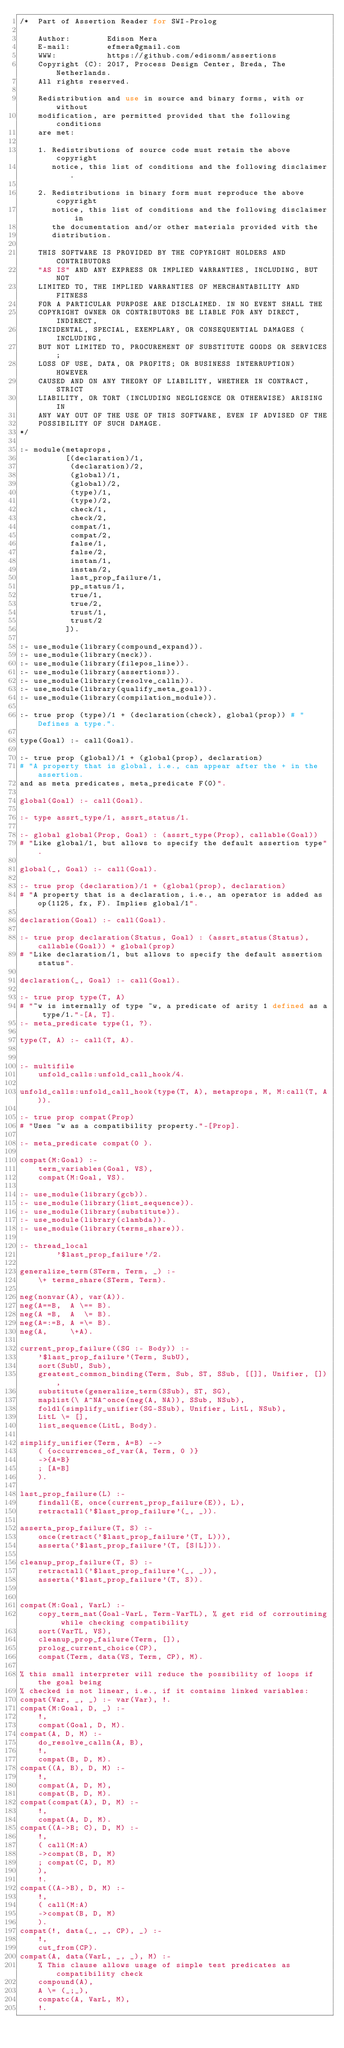Convert code to text. <code><loc_0><loc_0><loc_500><loc_500><_Perl_>/*  Part of Assertion Reader for SWI-Prolog

    Author:        Edison Mera
    E-mail:        efmera@gmail.com
    WWW:           https://github.com/edisonm/assertions
    Copyright (C): 2017, Process Design Center, Breda, The Netherlands.
    All rights reserved.

    Redistribution and use in source and binary forms, with or without
    modification, are permitted provided that the following conditions
    are met:

    1. Redistributions of source code must retain the above copyright
       notice, this list of conditions and the following disclaimer.

    2. Redistributions in binary form must reproduce the above copyright
       notice, this list of conditions and the following disclaimer in
       the documentation and/or other materials provided with the
       distribution.

    THIS SOFTWARE IS PROVIDED BY THE COPYRIGHT HOLDERS AND CONTRIBUTORS
    "AS IS" AND ANY EXPRESS OR IMPLIED WARRANTIES, INCLUDING, BUT NOT
    LIMITED TO, THE IMPLIED WARRANTIES OF MERCHANTABILITY AND FITNESS
    FOR A PARTICULAR PURPOSE ARE DISCLAIMED. IN NO EVENT SHALL THE
    COPYRIGHT OWNER OR CONTRIBUTORS BE LIABLE FOR ANY DIRECT, INDIRECT,
    INCIDENTAL, SPECIAL, EXEMPLARY, OR CONSEQUENTIAL DAMAGES (INCLUDING,
    BUT NOT LIMITED TO, PROCUREMENT OF SUBSTITUTE GOODS OR SERVICES;
    LOSS OF USE, DATA, OR PROFITS; OR BUSINESS INTERRUPTION) HOWEVER
    CAUSED AND ON ANY THEORY OF LIABILITY, WHETHER IN CONTRACT, STRICT
    LIABILITY, OR TORT (INCLUDING NEGLIGENCE OR OTHERWISE) ARISING IN
    ANY WAY OUT OF THE USE OF THIS SOFTWARE, EVEN IF ADVISED OF THE
    POSSIBILITY OF SUCH DAMAGE.
*/

:- module(metaprops,
          [(declaration)/1,
           (declaration)/2,
           (global)/1,
           (global)/2,
           (type)/1,
           (type)/2,
           check/1,
           check/2,
           compat/1,
           compat/2,
           false/1,
           false/2,
           instan/1,
           instan/2,
           last_prop_failure/1,
           pp_status/1,
           true/1,
           true/2,
           trust/1,
           trust/2
          ]).

:- use_module(library(compound_expand)).
:- use_module(library(neck)).
:- use_module(library(filepos_line)).
:- use_module(library(assertions)).
:- use_module(library(resolve_calln)).
:- use_module(library(qualify_meta_goal)).
:- use_module(library(compilation_module)).

:- true prop (type)/1 + (declaration(check), global(prop)) # "Defines a type.".

type(Goal) :- call(Goal).

:- true prop (global)/1 + (global(prop), declaration)
# "A property that is global, i.e., can appear after the + in the assertion.
and as meta predicates, meta_predicate F(0)".

global(Goal) :- call(Goal).

:- type assrt_type/1, assrt_status/1.

:- global global(Prop, Goal) : (assrt_type(Prop), callable(Goal))
# "Like global/1, but allows to specify the default assertion type".

global(_, Goal) :- call(Goal).

:- true prop (declaration)/1 + (global(prop), declaration)
# "A property that is a declaration, i.e., an operator is added as op(1125, fx, F). Implies global/1".

declaration(Goal) :- call(Goal).

:- true prop declaration(Status, Goal) : (assrt_status(Status), callable(Goal)) + global(prop)
# "Like declaration/1, but allows to specify the default assertion status".

declaration(_, Goal) :- call(Goal).

:- true prop type(T, A)
# "~w is internally of type ~w, a predicate of arity 1 defined as a type/1."-[A, T].
:- meta_predicate type(1, ?).

type(T, A) :- call(T, A).


:- multifile
    unfold_calls:unfold_call_hook/4.

unfold_calls:unfold_call_hook(type(T, A), metaprops, M, M:call(T, A)).

:- true prop compat(Prop)
# "Uses ~w as a compatibility property."-[Prop].

:- meta_predicate compat(0 ).

compat(M:Goal) :-
    term_variables(Goal, VS),
    compat(M:Goal, VS).

:- use_module(library(gcb)).
:- use_module(library(list_sequence)).
:- use_module(library(substitute)).
:- use_module(library(clambda)).
:- use_module(library(terms_share)).

:- thread_local
        '$last_prop_failure'/2.

generalize_term(STerm, Term, _) :-
    \+ terms_share(STerm, Term).

neg(nonvar(A), var(A)).
neg(A==B,  A \== B).
neg(A =B,  A  \= B).
neg(A=:=B, A =\= B).
neg(A,     \+A).

current_prop_failure((SG :- Body)) :-
    '$last_prop_failure'(Term, SubU),
    sort(SubU, Sub),
    greatest_common_binding(Term, Sub, ST, SSub, [[]], Unifier, []),
    substitute(generalize_term(SSub), ST, SG),
    maplist(\ A^NA^once(neg(A, NA)), SSub, NSub),
    foldl(simplify_unifier(SG-SSub), Unifier, LitL, NSub),
    LitL \= [],
    list_sequence(LitL, Body).

simplify_unifier(Term, A=B) -->
    ( {occurrences_of_var(A, Term, 0 )}
    ->{A=B}
    ; [A=B]
    ).

last_prop_failure(L) :-
    findall(E, once(current_prop_failure(E)), L),
    retractall('$last_prop_failure'(_, _)).

asserta_prop_failure(T, S) :-
    once(retract('$last_prop_failure'(T, L))),
    asserta('$last_prop_failure'(T, [S|L])).

cleanup_prop_failure(T, S) :-
    retractall('$last_prop_failure'(_, _)),
    asserta('$last_prop_failure'(T, S)).


compat(M:Goal, VarL) :-
    copy_term_nat(Goal-VarL, Term-VarTL), % get rid of corroutining while checking compatibility
    sort(VarTL, VS),
    cleanup_prop_failure(Term, []),
    prolog_current_choice(CP),
    compat(Term, data(VS, Term, CP), M).

% this small interpreter will reduce the possibility of loops if the goal being
% checked is not linear, i.e., if it contains linked variables:
compat(Var, _, _) :- var(Var), !.
compat(M:Goal, D, _) :-
    !,
    compat(Goal, D, M).
compat(A, D, M) :-
    do_resolve_calln(A, B),
    !,
    compat(B, D, M).
compat((A, B), D, M) :-
    !,
    compat(A, D, M),
    compat(B, D, M).
compat(compat(A), D, M) :-
    !,
    compat(A, D, M).
compat((A->B; C), D, M) :-
    !,
    ( call(M:A)
    ->compat(B, D, M)
    ; compat(C, D, M)
    ),
    !.
compat((A->B), D, M) :-
    !,
    ( call(M:A)
    ->compat(B, D, M)
    ).
compat(!, data(_, _, CP), _) :-
    !,
    cut_from(CP).
compat(A, data(VarL, _, _), M) :-
    % This clause allows usage of simple test predicates as compatibility check
    compound(A),
    A \= (_;_),
    compatc(A, VarL, M),
    !.</code> 